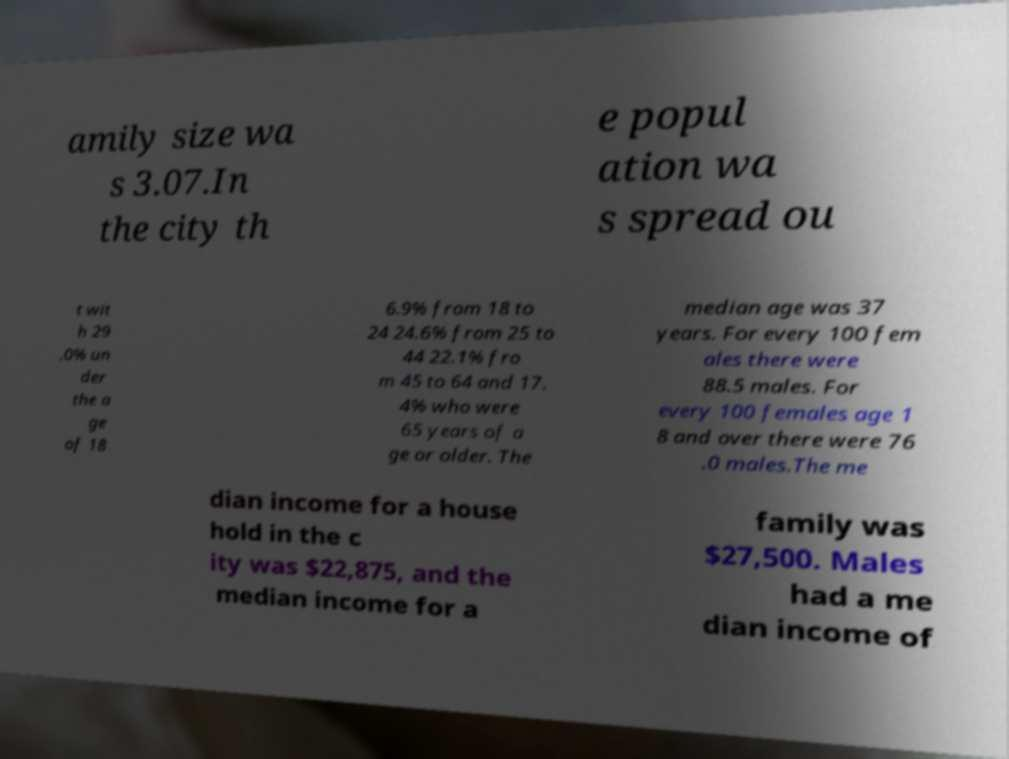What messages or text are displayed in this image? I need them in a readable, typed format. amily size wa s 3.07.In the city th e popul ation wa s spread ou t wit h 29 .0% un der the a ge of 18 6.9% from 18 to 24 24.6% from 25 to 44 22.1% fro m 45 to 64 and 17. 4% who were 65 years of a ge or older. The median age was 37 years. For every 100 fem ales there were 88.5 males. For every 100 females age 1 8 and over there were 76 .0 males.The me dian income for a house hold in the c ity was $22,875, and the median income for a family was $27,500. Males had a me dian income of 